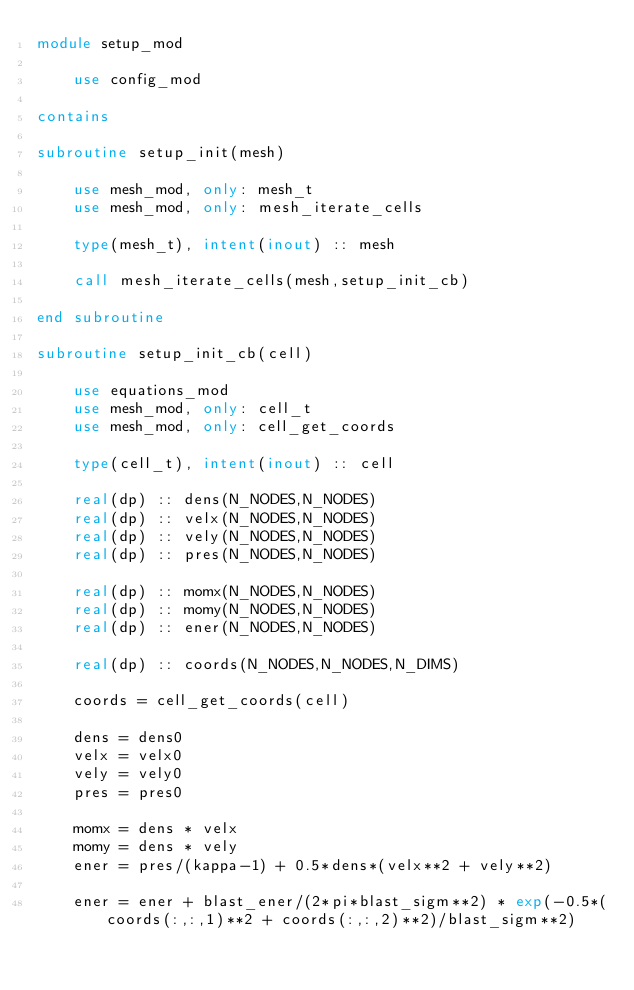<code> <loc_0><loc_0><loc_500><loc_500><_FORTRAN_>module setup_mod

    use config_mod

contains

subroutine setup_init(mesh)

    use mesh_mod, only: mesh_t
    use mesh_mod, only: mesh_iterate_cells

    type(mesh_t), intent(inout) :: mesh

    call mesh_iterate_cells(mesh,setup_init_cb)

end subroutine

subroutine setup_init_cb(cell)

    use equations_mod
    use mesh_mod, only: cell_t
    use mesh_mod, only: cell_get_coords

    type(cell_t), intent(inout) :: cell

    real(dp) :: dens(N_NODES,N_NODES)
    real(dp) :: velx(N_NODES,N_NODES)
    real(dp) :: vely(N_NODES,N_NODES)
    real(dp) :: pres(N_NODES,N_NODES)

    real(dp) :: momx(N_NODES,N_NODES)
    real(dp) :: momy(N_NODES,N_NODES)
    real(dp) :: ener(N_NODES,N_NODES)

    real(dp) :: coords(N_NODES,N_NODES,N_DIMS)

    coords = cell_get_coords(cell)

    dens = dens0
    velx = velx0
    vely = vely0
    pres = pres0

    momx = dens * velx
    momy = dens * vely
    ener = pres/(kappa-1) + 0.5*dens*(velx**2 + vely**2)

    ener = ener + blast_ener/(2*pi*blast_sigm**2) * exp(-0.5*(coords(:,:,1)**2 + coords(:,:,2)**2)/blast_sigm**2)
</code> 